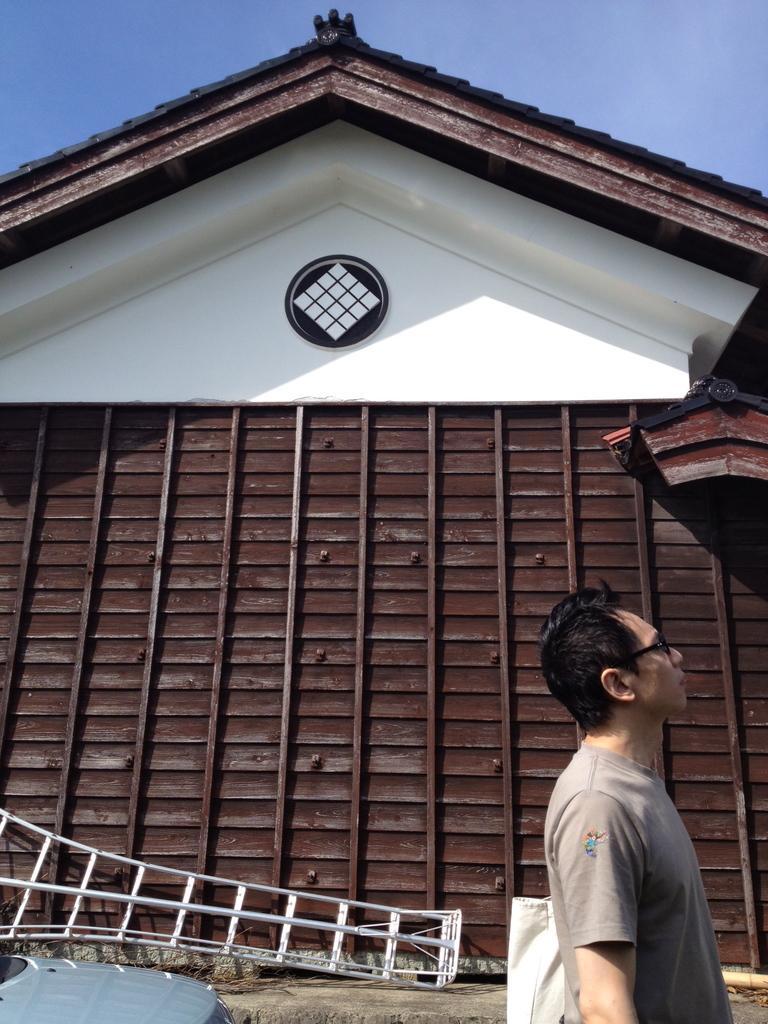How would you summarize this image in a sentence or two? At the center of the image there is a building and there is a person standing with his bag, behind him there is a vehicle and there is an object in front of the building. In the background there is the sky. 